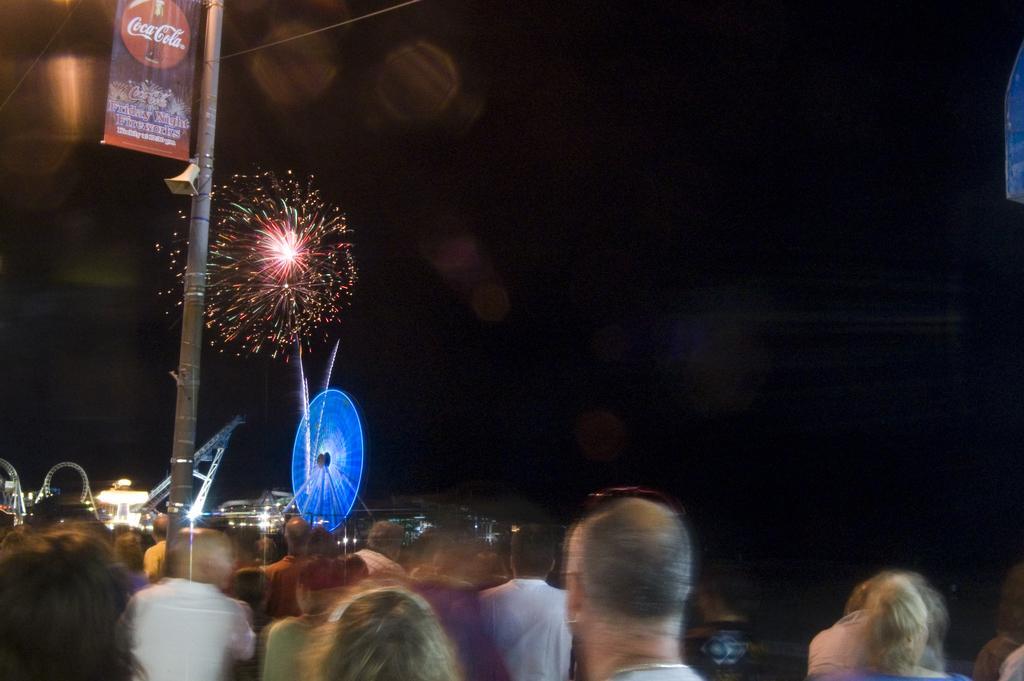Please provide a concise description of this image. This picture shows fireworks and we see a pole and we see few people Standing and a banner to the pole and few lights. 